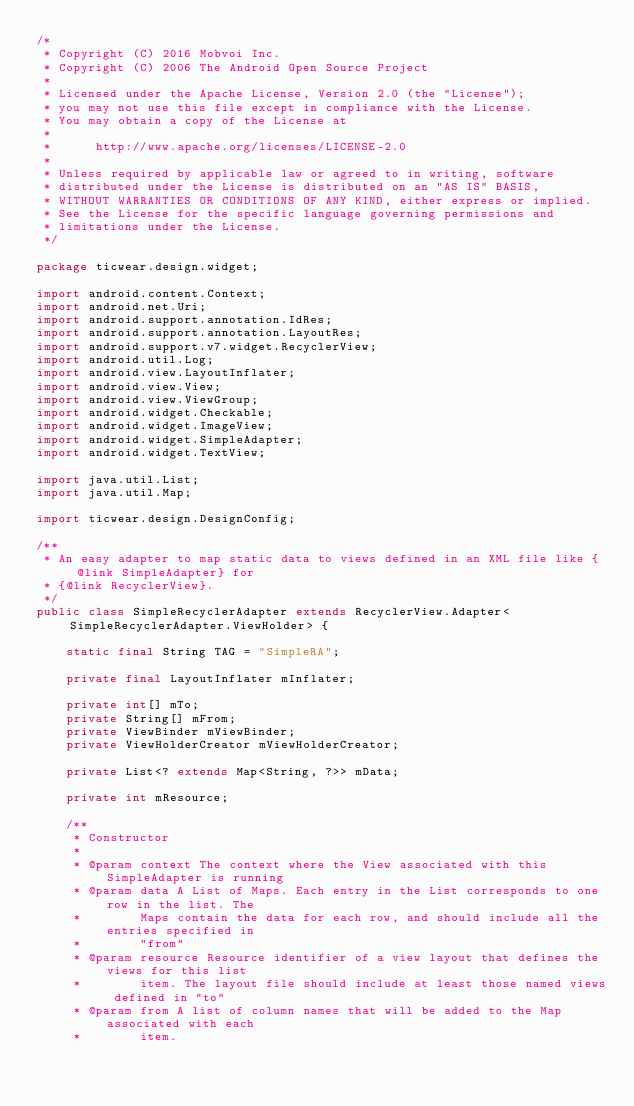<code> <loc_0><loc_0><loc_500><loc_500><_Java_>/*
 * Copyright (C) 2016 Mobvoi Inc.
 * Copyright (C) 2006 The Android Open Source Project
 *
 * Licensed under the Apache License, Version 2.0 (the "License");
 * you may not use this file except in compliance with the License.
 * You may obtain a copy of the License at
 *
 *      http://www.apache.org/licenses/LICENSE-2.0
 *
 * Unless required by applicable law or agreed to in writing, software
 * distributed under the License is distributed on an "AS IS" BASIS,
 * WITHOUT WARRANTIES OR CONDITIONS OF ANY KIND, either express or implied.
 * See the License for the specific language governing permissions and
 * limitations under the License.
 */

package ticwear.design.widget;

import android.content.Context;
import android.net.Uri;
import android.support.annotation.IdRes;
import android.support.annotation.LayoutRes;
import android.support.v7.widget.RecyclerView;
import android.util.Log;
import android.view.LayoutInflater;
import android.view.View;
import android.view.ViewGroup;
import android.widget.Checkable;
import android.widget.ImageView;
import android.widget.SimpleAdapter;
import android.widget.TextView;

import java.util.List;
import java.util.Map;

import ticwear.design.DesignConfig;

/**
 * An easy adapter to map static data to views defined in an XML file like {@link SimpleAdapter} for
 * {@link RecyclerView}.
 */
public class SimpleRecyclerAdapter extends RecyclerView.Adapter<SimpleRecyclerAdapter.ViewHolder> {

    static final String TAG = "SimpleRA";

    private final LayoutInflater mInflater;

    private int[] mTo;
    private String[] mFrom;
    private ViewBinder mViewBinder;
    private ViewHolderCreator mViewHolderCreator;

    private List<? extends Map<String, ?>> mData;

    private int mResource;

    /**
     * Constructor
     *
     * @param context The context where the View associated with this SimpleAdapter is running
     * @param data A List of Maps. Each entry in the List corresponds to one row in the list. The
     *        Maps contain the data for each row, and should include all the entries specified in
     *        "from"
     * @param resource Resource identifier of a view layout that defines the views for this list
     *        item. The layout file should include at least those named views defined in "to"
     * @param from A list of column names that will be added to the Map associated with each
     *        item.</code> 